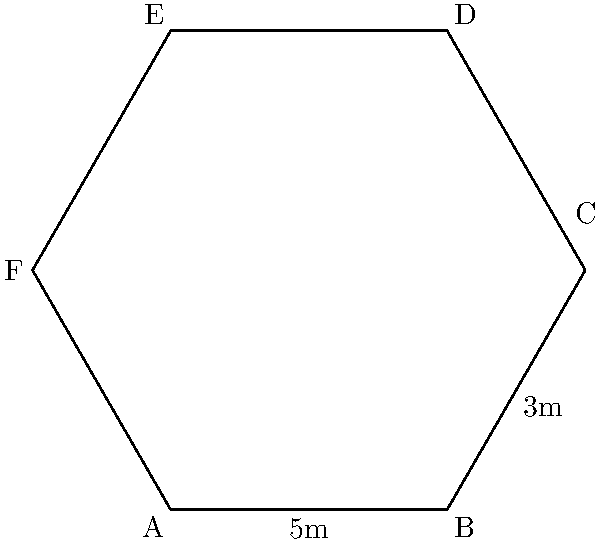Your hexagonal cacao storage facility has the shape shown in the diagram. If the length of side AB is 5 meters and the length of side BC is 3 meters, what is the perimeter of the entire facility? Let's approach this step-by-step:

1) First, we need to understand the properties of a regular hexagon:
   - All sides of a regular hexagon are equal in length.
   - A hexagon has 6 sides.

2) From the diagram, we can see that:
   - The length of side AB is 5 meters
   - The length of side BC is 3 meters

3) To calculate the perimeter, we need to add up the lengths of all sides:
   $$ \text{Perimeter} = AB + BC + CD + DE + EF + FA $$

4) Since AB = 5m and BC = 3m, and all sides of a regular hexagon are equal, we can deduce:
   $$ \text{Perimeter} = 5m + 3m + 5m + 5m + 5m + 3m $$

5) Now, let's sum up:
   $$ \text{Perimeter} = 5m + 3m + 5m + 5m + 5m + 3m = 26m $$

Therefore, the perimeter of the hexagonal cacao storage facility is 26 meters.
Answer: 26 meters 